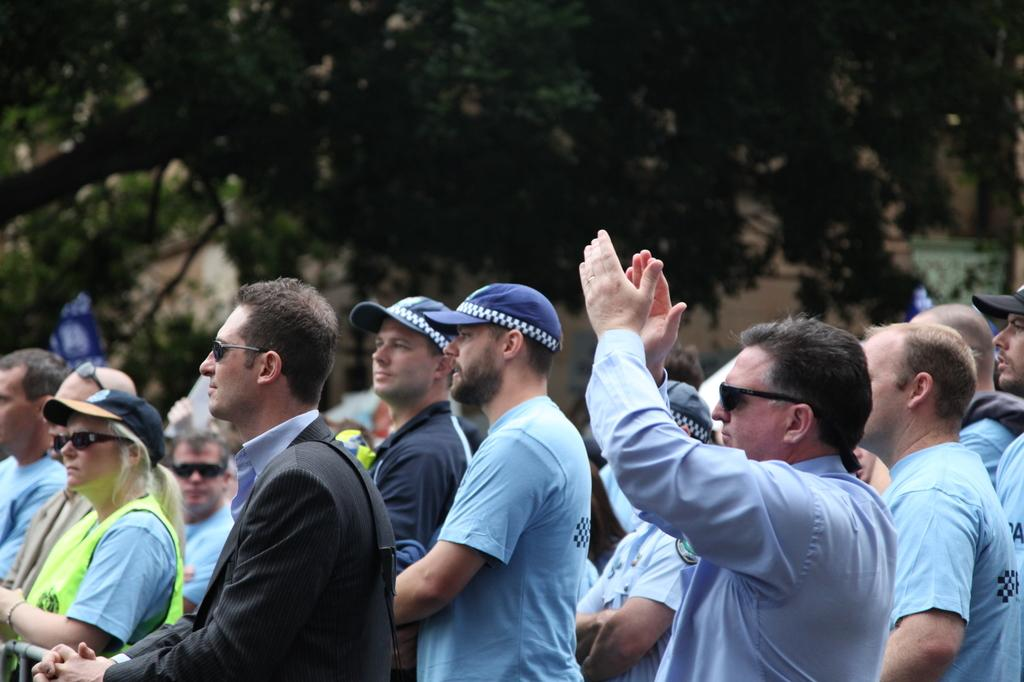What is the main subject of the image? The main subject of the image is people. Can you describe the position of the people in the image? The people are standing in the center of the image. What can be seen in the background of the image? There are trees at the top side of the image. What type of butter is being used by the people in the image? There is no butter present in the image. Can you describe the skirt worn by the people in the image? There is no mention of a skirt in the image, as the people are standing and not wearing any specific clothing. 